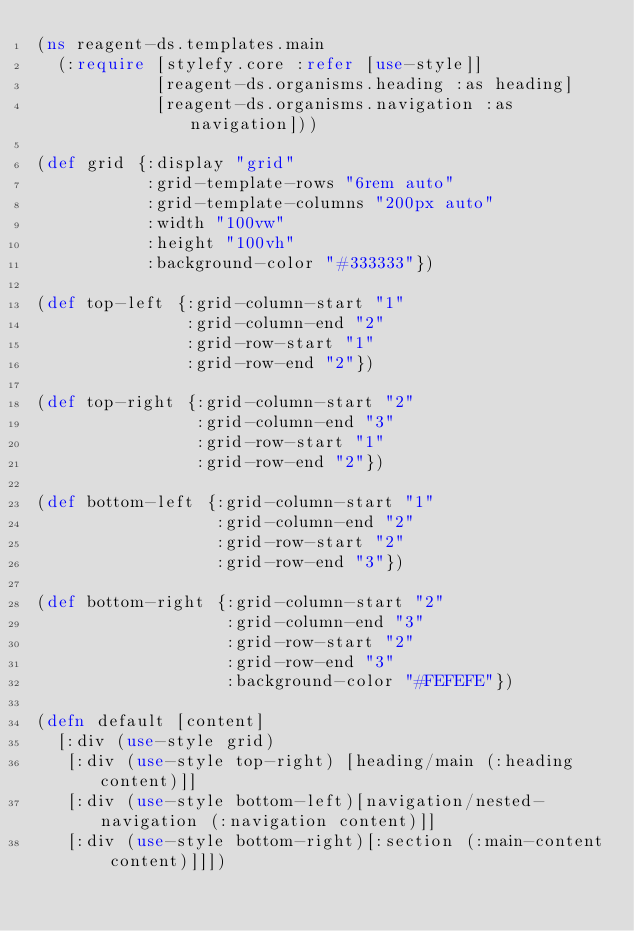Convert code to text. <code><loc_0><loc_0><loc_500><loc_500><_Clojure_>(ns reagent-ds.templates.main
  (:require [stylefy.core :refer [use-style]]
            [reagent-ds.organisms.heading :as heading]
            [reagent-ds.organisms.navigation :as navigation]))

(def grid {:display "grid"
           :grid-template-rows "6rem auto"
           :grid-template-columns "200px auto"
           :width "100vw"
           :height "100vh"
           :background-color "#333333"})

(def top-left {:grid-column-start "1"
               :grid-column-end "2"
               :grid-row-start "1"
               :grid-row-end "2"})

(def top-right {:grid-column-start "2"
                :grid-column-end "3"
                :grid-row-start "1"
                :grid-row-end "2"})

(def bottom-left {:grid-column-start "1"
                  :grid-column-end "2"
                  :grid-row-start "2"
                  :grid-row-end "3"})

(def bottom-right {:grid-column-start "2"
                   :grid-column-end "3"
                   :grid-row-start "2"
                   :grid-row-end "3"
                   :background-color "#FEFEFE"})

(defn default [content]
  [:div (use-style grid)
   [:div (use-style top-right) [heading/main (:heading content)]]
   [:div (use-style bottom-left)[navigation/nested-navigation (:navigation content)]]
   [:div (use-style bottom-right)[:section (:main-content content)]]])</code> 